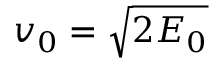<formula> <loc_0><loc_0><loc_500><loc_500>v _ { 0 } = \sqrt { 2 E _ { 0 } }</formula> 